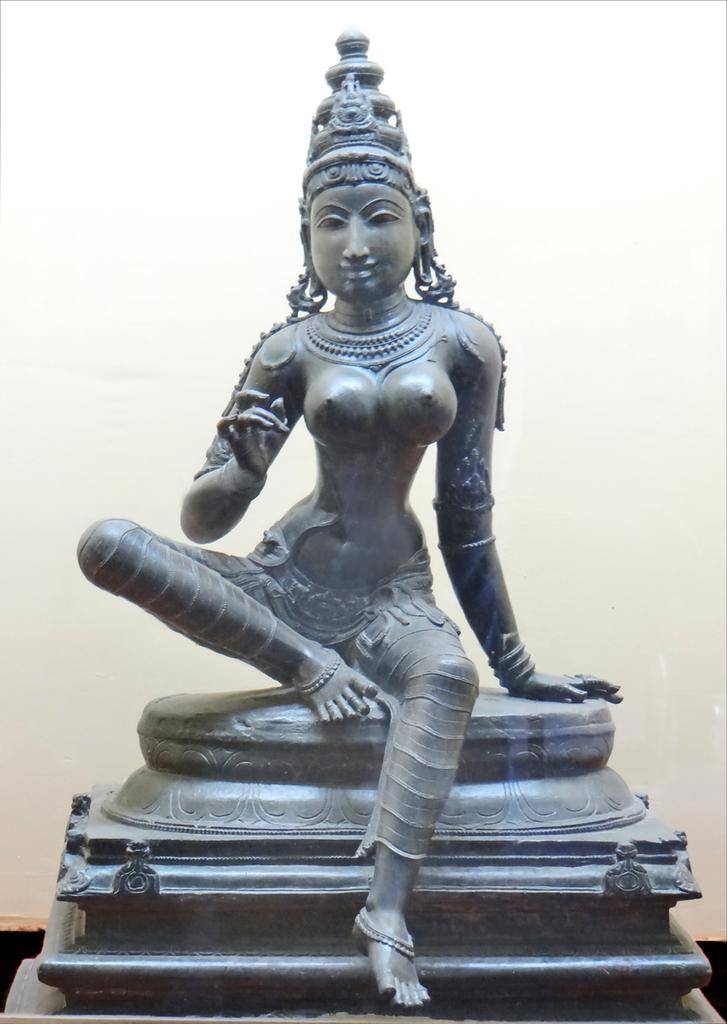What is the main subject of the image? There is a sculpture in the image. How is the sculpture positioned in the image? The sculpture is on a stand. What can be seen in the background of the image? There is a white wall in the background of the image. What color is the yak standing next to the sculpture in the image? There is no yak present in the image; it only features a sculpture on a stand with a white wall in the background. 